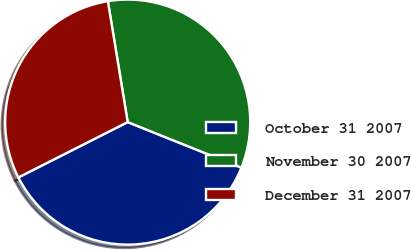<chart> <loc_0><loc_0><loc_500><loc_500><pie_chart><fcel>October 31 2007<fcel>November 30 2007<fcel>December 31 2007<nl><fcel>36.48%<fcel>33.65%<fcel>29.87%<nl></chart> 